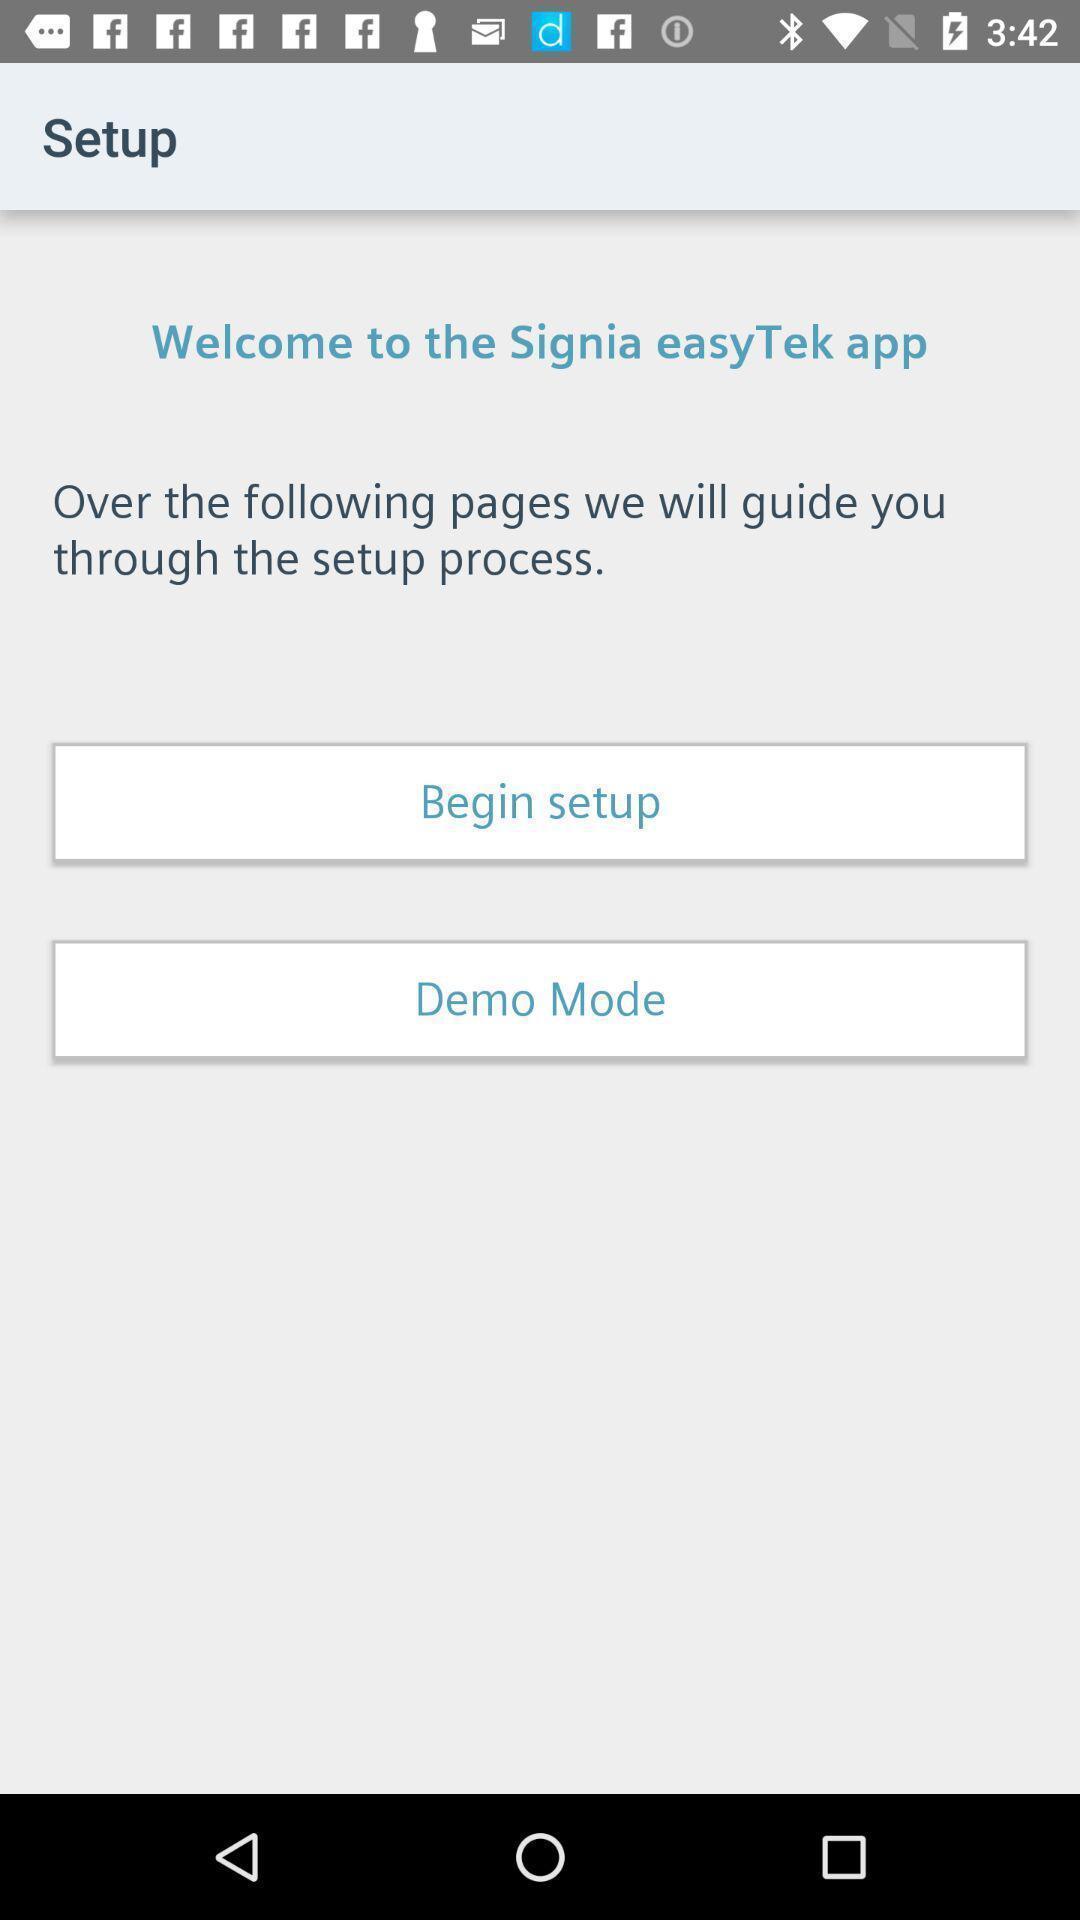Tell me about the visual elements in this screen capture. Welcome setup details of a entertainment app. 